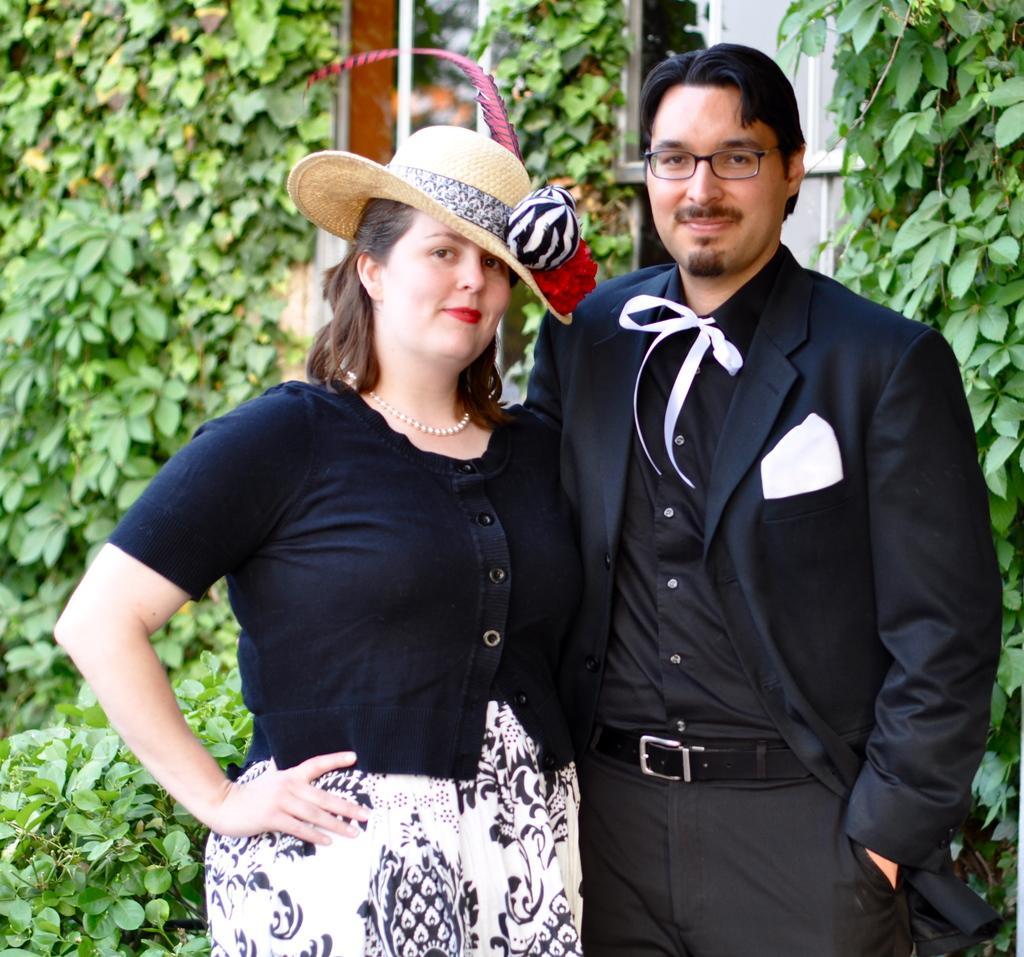In one or two sentences, can you explain what this image depicts? In the foreground of the picture there is a couple standing, they are wearing black colored dresses. In the middle of the picture there are plants, iron frame and building. 